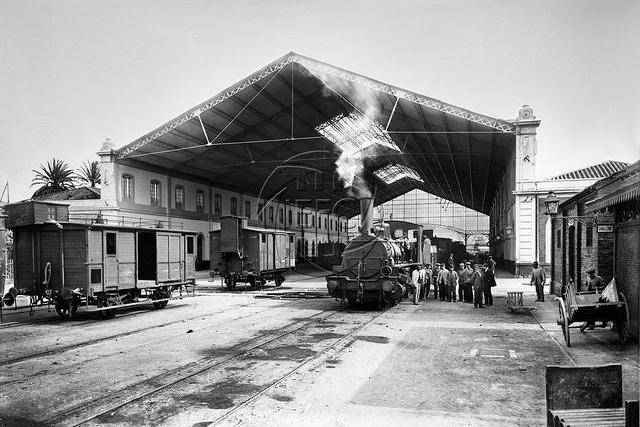How many trains can be seen?
Give a very brief answer. 3. How many giraffes can been seen?
Give a very brief answer. 0. 